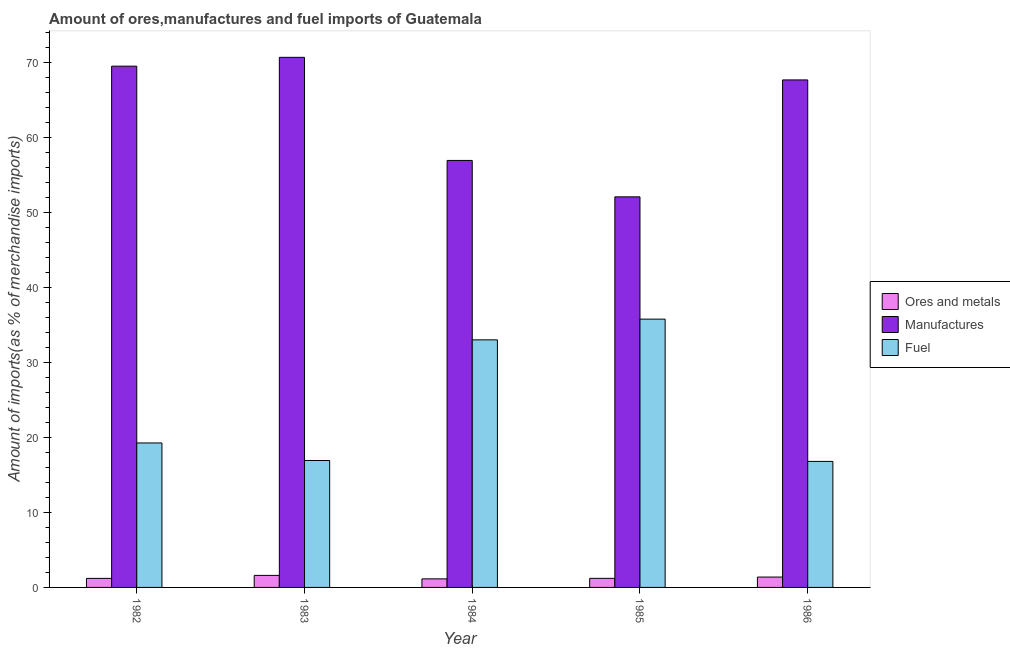How many different coloured bars are there?
Offer a very short reply. 3. How many groups of bars are there?
Give a very brief answer. 5. Are the number of bars per tick equal to the number of legend labels?
Offer a very short reply. Yes. In how many cases, is the number of bars for a given year not equal to the number of legend labels?
Offer a terse response. 0. What is the percentage of ores and metals imports in 1985?
Ensure brevity in your answer.  1.21. Across all years, what is the maximum percentage of fuel imports?
Keep it short and to the point. 35.75. Across all years, what is the minimum percentage of manufactures imports?
Keep it short and to the point. 52.05. In which year was the percentage of ores and metals imports maximum?
Give a very brief answer. 1983. What is the total percentage of manufactures imports in the graph?
Ensure brevity in your answer.  316.7. What is the difference between the percentage of fuel imports in 1983 and that in 1984?
Your answer should be compact. -16.08. What is the difference between the percentage of ores and metals imports in 1985 and the percentage of manufactures imports in 1984?
Your response must be concise. 0.07. What is the average percentage of fuel imports per year?
Make the answer very short. 24.34. In the year 1985, what is the difference between the percentage of fuel imports and percentage of manufactures imports?
Provide a succinct answer. 0. In how many years, is the percentage of ores and metals imports greater than 66 %?
Offer a terse response. 0. What is the ratio of the percentage of ores and metals imports in 1983 to that in 1986?
Give a very brief answer. 1.16. What is the difference between the highest and the second highest percentage of fuel imports?
Offer a very short reply. 2.76. What is the difference between the highest and the lowest percentage of ores and metals imports?
Offer a terse response. 0.46. In how many years, is the percentage of fuel imports greater than the average percentage of fuel imports taken over all years?
Your answer should be very brief. 2. What does the 1st bar from the left in 1983 represents?
Offer a very short reply. Ores and metals. What does the 2nd bar from the right in 1985 represents?
Offer a terse response. Manufactures. How many bars are there?
Give a very brief answer. 15. How many years are there in the graph?
Provide a short and direct response. 5. Are the values on the major ticks of Y-axis written in scientific E-notation?
Make the answer very short. No. Does the graph contain any zero values?
Make the answer very short. No. What is the title of the graph?
Give a very brief answer. Amount of ores,manufactures and fuel imports of Guatemala. Does "Oil" appear as one of the legend labels in the graph?
Keep it short and to the point. No. What is the label or title of the Y-axis?
Your answer should be very brief. Amount of imports(as % of merchandise imports). What is the Amount of imports(as % of merchandise imports) of Ores and metals in 1982?
Offer a terse response. 1.2. What is the Amount of imports(as % of merchandise imports) of Manufactures in 1982?
Offer a terse response. 69.47. What is the Amount of imports(as % of merchandise imports) of Fuel in 1982?
Make the answer very short. 19.25. What is the Amount of imports(as % of merchandise imports) in Ores and metals in 1983?
Your answer should be compact. 1.6. What is the Amount of imports(as % of merchandise imports) in Manufactures in 1983?
Your response must be concise. 70.64. What is the Amount of imports(as % of merchandise imports) in Fuel in 1983?
Ensure brevity in your answer.  16.91. What is the Amount of imports(as % of merchandise imports) in Ores and metals in 1984?
Your answer should be very brief. 1.14. What is the Amount of imports(as % of merchandise imports) in Manufactures in 1984?
Provide a succinct answer. 56.9. What is the Amount of imports(as % of merchandise imports) in Fuel in 1984?
Ensure brevity in your answer.  32.99. What is the Amount of imports(as % of merchandise imports) of Ores and metals in 1985?
Provide a short and direct response. 1.21. What is the Amount of imports(as % of merchandise imports) in Manufactures in 1985?
Keep it short and to the point. 52.05. What is the Amount of imports(as % of merchandise imports) in Fuel in 1985?
Make the answer very short. 35.75. What is the Amount of imports(as % of merchandise imports) of Ores and metals in 1986?
Your response must be concise. 1.38. What is the Amount of imports(as % of merchandise imports) of Manufactures in 1986?
Offer a very short reply. 67.63. What is the Amount of imports(as % of merchandise imports) of Fuel in 1986?
Make the answer very short. 16.8. Across all years, what is the maximum Amount of imports(as % of merchandise imports) of Ores and metals?
Keep it short and to the point. 1.6. Across all years, what is the maximum Amount of imports(as % of merchandise imports) in Manufactures?
Provide a short and direct response. 70.64. Across all years, what is the maximum Amount of imports(as % of merchandise imports) of Fuel?
Provide a succinct answer. 35.75. Across all years, what is the minimum Amount of imports(as % of merchandise imports) of Ores and metals?
Ensure brevity in your answer.  1.14. Across all years, what is the minimum Amount of imports(as % of merchandise imports) in Manufactures?
Offer a very short reply. 52.05. Across all years, what is the minimum Amount of imports(as % of merchandise imports) of Fuel?
Make the answer very short. 16.8. What is the total Amount of imports(as % of merchandise imports) of Ores and metals in the graph?
Give a very brief answer. 6.54. What is the total Amount of imports(as % of merchandise imports) in Manufactures in the graph?
Keep it short and to the point. 316.7. What is the total Amount of imports(as % of merchandise imports) of Fuel in the graph?
Provide a succinct answer. 121.71. What is the difference between the Amount of imports(as % of merchandise imports) of Ores and metals in 1982 and that in 1983?
Your answer should be compact. -0.4. What is the difference between the Amount of imports(as % of merchandise imports) in Manufactures in 1982 and that in 1983?
Provide a short and direct response. -1.18. What is the difference between the Amount of imports(as % of merchandise imports) in Fuel in 1982 and that in 1983?
Keep it short and to the point. 2.34. What is the difference between the Amount of imports(as % of merchandise imports) in Ores and metals in 1982 and that in 1984?
Offer a terse response. 0.06. What is the difference between the Amount of imports(as % of merchandise imports) of Manufactures in 1982 and that in 1984?
Make the answer very short. 12.56. What is the difference between the Amount of imports(as % of merchandise imports) in Fuel in 1982 and that in 1984?
Give a very brief answer. -13.74. What is the difference between the Amount of imports(as % of merchandise imports) of Ores and metals in 1982 and that in 1985?
Keep it short and to the point. -0. What is the difference between the Amount of imports(as % of merchandise imports) in Manufactures in 1982 and that in 1985?
Give a very brief answer. 17.42. What is the difference between the Amount of imports(as % of merchandise imports) in Fuel in 1982 and that in 1985?
Your answer should be compact. -16.5. What is the difference between the Amount of imports(as % of merchandise imports) of Ores and metals in 1982 and that in 1986?
Provide a short and direct response. -0.18. What is the difference between the Amount of imports(as % of merchandise imports) of Manufactures in 1982 and that in 1986?
Ensure brevity in your answer.  1.83. What is the difference between the Amount of imports(as % of merchandise imports) of Fuel in 1982 and that in 1986?
Your answer should be compact. 2.46. What is the difference between the Amount of imports(as % of merchandise imports) of Ores and metals in 1983 and that in 1984?
Keep it short and to the point. 0.46. What is the difference between the Amount of imports(as % of merchandise imports) in Manufactures in 1983 and that in 1984?
Keep it short and to the point. 13.74. What is the difference between the Amount of imports(as % of merchandise imports) of Fuel in 1983 and that in 1984?
Provide a short and direct response. -16.08. What is the difference between the Amount of imports(as % of merchandise imports) in Ores and metals in 1983 and that in 1985?
Provide a succinct answer. 0.39. What is the difference between the Amount of imports(as % of merchandise imports) in Manufactures in 1983 and that in 1985?
Keep it short and to the point. 18.59. What is the difference between the Amount of imports(as % of merchandise imports) in Fuel in 1983 and that in 1985?
Your answer should be compact. -18.84. What is the difference between the Amount of imports(as % of merchandise imports) in Ores and metals in 1983 and that in 1986?
Provide a short and direct response. 0.22. What is the difference between the Amount of imports(as % of merchandise imports) in Manufactures in 1983 and that in 1986?
Offer a terse response. 3.01. What is the difference between the Amount of imports(as % of merchandise imports) of Fuel in 1983 and that in 1986?
Provide a short and direct response. 0.12. What is the difference between the Amount of imports(as % of merchandise imports) in Ores and metals in 1984 and that in 1985?
Ensure brevity in your answer.  -0.07. What is the difference between the Amount of imports(as % of merchandise imports) of Manufactures in 1984 and that in 1985?
Ensure brevity in your answer.  4.85. What is the difference between the Amount of imports(as % of merchandise imports) of Fuel in 1984 and that in 1985?
Your answer should be very brief. -2.76. What is the difference between the Amount of imports(as % of merchandise imports) in Ores and metals in 1984 and that in 1986?
Offer a terse response. -0.24. What is the difference between the Amount of imports(as % of merchandise imports) of Manufactures in 1984 and that in 1986?
Offer a terse response. -10.73. What is the difference between the Amount of imports(as % of merchandise imports) of Fuel in 1984 and that in 1986?
Ensure brevity in your answer.  16.2. What is the difference between the Amount of imports(as % of merchandise imports) in Ores and metals in 1985 and that in 1986?
Provide a succinct answer. -0.17. What is the difference between the Amount of imports(as % of merchandise imports) of Manufactures in 1985 and that in 1986?
Your response must be concise. -15.58. What is the difference between the Amount of imports(as % of merchandise imports) of Fuel in 1985 and that in 1986?
Keep it short and to the point. 18.96. What is the difference between the Amount of imports(as % of merchandise imports) of Ores and metals in 1982 and the Amount of imports(as % of merchandise imports) of Manufactures in 1983?
Your answer should be very brief. -69.44. What is the difference between the Amount of imports(as % of merchandise imports) in Ores and metals in 1982 and the Amount of imports(as % of merchandise imports) in Fuel in 1983?
Keep it short and to the point. -15.71. What is the difference between the Amount of imports(as % of merchandise imports) of Manufactures in 1982 and the Amount of imports(as % of merchandise imports) of Fuel in 1983?
Keep it short and to the point. 52.55. What is the difference between the Amount of imports(as % of merchandise imports) of Ores and metals in 1982 and the Amount of imports(as % of merchandise imports) of Manufactures in 1984?
Your answer should be very brief. -55.7. What is the difference between the Amount of imports(as % of merchandise imports) of Ores and metals in 1982 and the Amount of imports(as % of merchandise imports) of Fuel in 1984?
Your answer should be compact. -31.79. What is the difference between the Amount of imports(as % of merchandise imports) of Manufactures in 1982 and the Amount of imports(as % of merchandise imports) of Fuel in 1984?
Your response must be concise. 36.47. What is the difference between the Amount of imports(as % of merchandise imports) of Ores and metals in 1982 and the Amount of imports(as % of merchandise imports) of Manufactures in 1985?
Your answer should be very brief. -50.85. What is the difference between the Amount of imports(as % of merchandise imports) in Ores and metals in 1982 and the Amount of imports(as % of merchandise imports) in Fuel in 1985?
Offer a very short reply. -34.55. What is the difference between the Amount of imports(as % of merchandise imports) of Manufactures in 1982 and the Amount of imports(as % of merchandise imports) of Fuel in 1985?
Offer a very short reply. 33.71. What is the difference between the Amount of imports(as % of merchandise imports) of Ores and metals in 1982 and the Amount of imports(as % of merchandise imports) of Manufactures in 1986?
Offer a terse response. -66.43. What is the difference between the Amount of imports(as % of merchandise imports) in Ores and metals in 1982 and the Amount of imports(as % of merchandise imports) in Fuel in 1986?
Provide a short and direct response. -15.59. What is the difference between the Amount of imports(as % of merchandise imports) in Manufactures in 1982 and the Amount of imports(as % of merchandise imports) in Fuel in 1986?
Provide a succinct answer. 52.67. What is the difference between the Amount of imports(as % of merchandise imports) of Ores and metals in 1983 and the Amount of imports(as % of merchandise imports) of Manufactures in 1984?
Your response must be concise. -55.3. What is the difference between the Amount of imports(as % of merchandise imports) of Ores and metals in 1983 and the Amount of imports(as % of merchandise imports) of Fuel in 1984?
Provide a succinct answer. -31.39. What is the difference between the Amount of imports(as % of merchandise imports) of Manufactures in 1983 and the Amount of imports(as % of merchandise imports) of Fuel in 1984?
Provide a succinct answer. 37.65. What is the difference between the Amount of imports(as % of merchandise imports) of Ores and metals in 1983 and the Amount of imports(as % of merchandise imports) of Manufactures in 1985?
Your answer should be compact. -50.45. What is the difference between the Amount of imports(as % of merchandise imports) in Ores and metals in 1983 and the Amount of imports(as % of merchandise imports) in Fuel in 1985?
Offer a terse response. -34.15. What is the difference between the Amount of imports(as % of merchandise imports) of Manufactures in 1983 and the Amount of imports(as % of merchandise imports) of Fuel in 1985?
Give a very brief answer. 34.89. What is the difference between the Amount of imports(as % of merchandise imports) in Ores and metals in 1983 and the Amount of imports(as % of merchandise imports) in Manufactures in 1986?
Make the answer very short. -66.03. What is the difference between the Amount of imports(as % of merchandise imports) of Ores and metals in 1983 and the Amount of imports(as % of merchandise imports) of Fuel in 1986?
Ensure brevity in your answer.  -15.19. What is the difference between the Amount of imports(as % of merchandise imports) of Manufactures in 1983 and the Amount of imports(as % of merchandise imports) of Fuel in 1986?
Your response must be concise. 53.85. What is the difference between the Amount of imports(as % of merchandise imports) of Ores and metals in 1984 and the Amount of imports(as % of merchandise imports) of Manufactures in 1985?
Provide a succinct answer. -50.91. What is the difference between the Amount of imports(as % of merchandise imports) of Ores and metals in 1984 and the Amount of imports(as % of merchandise imports) of Fuel in 1985?
Make the answer very short. -34.61. What is the difference between the Amount of imports(as % of merchandise imports) of Manufactures in 1984 and the Amount of imports(as % of merchandise imports) of Fuel in 1985?
Your answer should be very brief. 21.15. What is the difference between the Amount of imports(as % of merchandise imports) of Ores and metals in 1984 and the Amount of imports(as % of merchandise imports) of Manufactures in 1986?
Ensure brevity in your answer.  -66.49. What is the difference between the Amount of imports(as % of merchandise imports) in Ores and metals in 1984 and the Amount of imports(as % of merchandise imports) in Fuel in 1986?
Keep it short and to the point. -15.66. What is the difference between the Amount of imports(as % of merchandise imports) of Manufactures in 1984 and the Amount of imports(as % of merchandise imports) of Fuel in 1986?
Give a very brief answer. 40.11. What is the difference between the Amount of imports(as % of merchandise imports) in Ores and metals in 1985 and the Amount of imports(as % of merchandise imports) in Manufactures in 1986?
Your answer should be very brief. -66.42. What is the difference between the Amount of imports(as % of merchandise imports) in Ores and metals in 1985 and the Amount of imports(as % of merchandise imports) in Fuel in 1986?
Offer a terse response. -15.59. What is the difference between the Amount of imports(as % of merchandise imports) of Manufactures in 1985 and the Amount of imports(as % of merchandise imports) of Fuel in 1986?
Provide a short and direct response. 35.26. What is the average Amount of imports(as % of merchandise imports) in Ores and metals per year?
Offer a terse response. 1.31. What is the average Amount of imports(as % of merchandise imports) of Manufactures per year?
Your response must be concise. 63.34. What is the average Amount of imports(as % of merchandise imports) in Fuel per year?
Make the answer very short. 24.34. In the year 1982, what is the difference between the Amount of imports(as % of merchandise imports) in Ores and metals and Amount of imports(as % of merchandise imports) in Manufactures?
Keep it short and to the point. -68.26. In the year 1982, what is the difference between the Amount of imports(as % of merchandise imports) of Ores and metals and Amount of imports(as % of merchandise imports) of Fuel?
Keep it short and to the point. -18.05. In the year 1982, what is the difference between the Amount of imports(as % of merchandise imports) in Manufactures and Amount of imports(as % of merchandise imports) in Fuel?
Ensure brevity in your answer.  50.21. In the year 1983, what is the difference between the Amount of imports(as % of merchandise imports) in Ores and metals and Amount of imports(as % of merchandise imports) in Manufactures?
Give a very brief answer. -69.04. In the year 1983, what is the difference between the Amount of imports(as % of merchandise imports) of Ores and metals and Amount of imports(as % of merchandise imports) of Fuel?
Offer a very short reply. -15.31. In the year 1983, what is the difference between the Amount of imports(as % of merchandise imports) of Manufactures and Amount of imports(as % of merchandise imports) of Fuel?
Your answer should be compact. 53.73. In the year 1984, what is the difference between the Amount of imports(as % of merchandise imports) of Ores and metals and Amount of imports(as % of merchandise imports) of Manufactures?
Ensure brevity in your answer.  -55.76. In the year 1984, what is the difference between the Amount of imports(as % of merchandise imports) of Ores and metals and Amount of imports(as % of merchandise imports) of Fuel?
Give a very brief answer. -31.85. In the year 1984, what is the difference between the Amount of imports(as % of merchandise imports) of Manufactures and Amount of imports(as % of merchandise imports) of Fuel?
Give a very brief answer. 23.91. In the year 1985, what is the difference between the Amount of imports(as % of merchandise imports) of Ores and metals and Amount of imports(as % of merchandise imports) of Manufactures?
Ensure brevity in your answer.  -50.84. In the year 1985, what is the difference between the Amount of imports(as % of merchandise imports) in Ores and metals and Amount of imports(as % of merchandise imports) in Fuel?
Offer a very short reply. -34.54. In the year 1985, what is the difference between the Amount of imports(as % of merchandise imports) in Manufactures and Amount of imports(as % of merchandise imports) in Fuel?
Your answer should be compact. 16.3. In the year 1986, what is the difference between the Amount of imports(as % of merchandise imports) of Ores and metals and Amount of imports(as % of merchandise imports) of Manufactures?
Make the answer very short. -66.25. In the year 1986, what is the difference between the Amount of imports(as % of merchandise imports) in Ores and metals and Amount of imports(as % of merchandise imports) in Fuel?
Give a very brief answer. -15.41. In the year 1986, what is the difference between the Amount of imports(as % of merchandise imports) in Manufactures and Amount of imports(as % of merchandise imports) in Fuel?
Your response must be concise. 50.84. What is the ratio of the Amount of imports(as % of merchandise imports) of Ores and metals in 1982 to that in 1983?
Provide a short and direct response. 0.75. What is the ratio of the Amount of imports(as % of merchandise imports) in Manufactures in 1982 to that in 1983?
Ensure brevity in your answer.  0.98. What is the ratio of the Amount of imports(as % of merchandise imports) in Fuel in 1982 to that in 1983?
Offer a very short reply. 1.14. What is the ratio of the Amount of imports(as % of merchandise imports) of Ores and metals in 1982 to that in 1984?
Your answer should be very brief. 1.06. What is the ratio of the Amount of imports(as % of merchandise imports) of Manufactures in 1982 to that in 1984?
Give a very brief answer. 1.22. What is the ratio of the Amount of imports(as % of merchandise imports) in Fuel in 1982 to that in 1984?
Offer a very short reply. 0.58. What is the ratio of the Amount of imports(as % of merchandise imports) of Ores and metals in 1982 to that in 1985?
Give a very brief answer. 1. What is the ratio of the Amount of imports(as % of merchandise imports) of Manufactures in 1982 to that in 1985?
Offer a very short reply. 1.33. What is the ratio of the Amount of imports(as % of merchandise imports) in Fuel in 1982 to that in 1985?
Keep it short and to the point. 0.54. What is the ratio of the Amount of imports(as % of merchandise imports) of Ores and metals in 1982 to that in 1986?
Your answer should be compact. 0.87. What is the ratio of the Amount of imports(as % of merchandise imports) in Manufactures in 1982 to that in 1986?
Provide a succinct answer. 1.03. What is the ratio of the Amount of imports(as % of merchandise imports) in Fuel in 1982 to that in 1986?
Ensure brevity in your answer.  1.15. What is the ratio of the Amount of imports(as % of merchandise imports) of Ores and metals in 1983 to that in 1984?
Your response must be concise. 1.41. What is the ratio of the Amount of imports(as % of merchandise imports) in Manufactures in 1983 to that in 1984?
Ensure brevity in your answer.  1.24. What is the ratio of the Amount of imports(as % of merchandise imports) of Fuel in 1983 to that in 1984?
Your answer should be compact. 0.51. What is the ratio of the Amount of imports(as % of merchandise imports) of Ores and metals in 1983 to that in 1985?
Give a very brief answer. 1.32. What is the ratio of the Amount of imports(as % of merchandise imports) of Manufactures in 1983 to that in 1985?
Provide a succinct answer. 1.36. What is the ratio of the Amount of imports(as % of merchandise imports) in Fuel in 1983 to that in 1985?
Offer a terse response. 0.47. What is the ratio of the Amount of imports(as % of merchandise imports) of Ores and metals in 1983 to that in 1986?
Your answer should be very brief. 1.16. What is the ratio of the Amount of imports(as % of merchandise imports) in Manufactures in 1983 to that in 1986?
Keep it short and to the point. 1.04. What is the ratio of the Amount of imports(as % of merchandise imports) of Ores and metals in 1984 to that in 1985?
Provide a succinct answer. 0.94. What is the ratio of the Amount of imports(as % of merchandise imports) in Manufactures in 1984 to that in 1985?
Keep it short and to the point. 1.09. What is the ratio of the Amount of imports(as % of merchandise imports) in Fuel in 1984 to that in 1985?
Ensure brevity in your answer.  0.92. What is the ratio of the Amount of imports(as % of merchandise imports) of Ores and metals in 1984 to that in 1986?
Give a very brief answer. 0.82. What is the ratio of the Amount of imports(as % of merchandise imports) of Manufactures in 1984 to that in 1986?
Ensure brevity in your answer.  0.84. What is the ratio of the Amount of imports(as % of merchandise imports) of Fuel in 1984 to that in 1986?
Offer a very short reply. 1.96. What is the ratio of the Amount of imports(as % of merchandise imports) of Ores and metals in 1985 to that in 1986?
Ensure brevity in your answer.  0.88. What is the ratio of the Amount of imports(as % of merchandise imports) in Manufactures in 1985 to that in 1986?
Keep it short and to the point. 0.77. What is the ratio of the Amount of imports(as % of merchandise imports) in Fuel in 1985 to that in 1986?
Ensure brevity in your answer.  2.13. What is the difference between the highest and the second highest Amount of imports(as % of merchandise imports) in Ores and metals?
Make the answer very short. 0.22. What is the difference between the highest and the second highest Amount of imports(as % of merchandise imports) of Manufactures?
Your response must be concise. 1.18. What is the difference between the highest and the second highest Amount of imports(as % of merchandise imports) in Fuel?
Provide a short and direct response. 2.76. What is the difference between the highest and the lowest Amount of imports(as % of merchandise imports) in Ores and metals?
Provide a short and direct response. 0.46. What is the difference between the highest and the lowest Amount of imports(as % of merchandise imports) of Manufactures?
Provide a short and direct response. 18.59. What is the difference between the highest and the lowest Amount of imports(as % of merchandise imports) in Fuel?
Your answer should be compact. 18.96. 